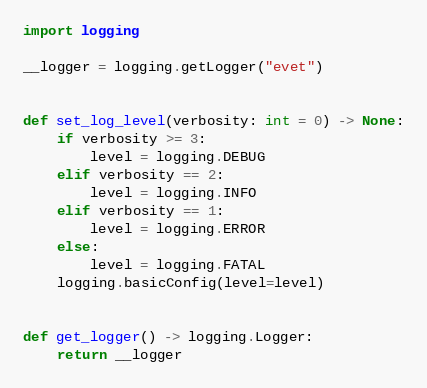Convert code to text. <code><loc_0><loc_0><loc_500><loc_500><_Python_>import logging

__logger = logging.getLogger("evet")


def set_log_level(verbosity: int = 0) -> None:
    if verbosity >= 3:
        level = logging.DEBUG
    elif verbosity == 2:
        level = logging.INFO
    elif verbosity == 1:
        level = logging.ERROR
    else:
        level = logging.FATAL
    logging.basicConfig(level=level)


def get_logger() -> logging.Logger:
    return __logger
</code> 